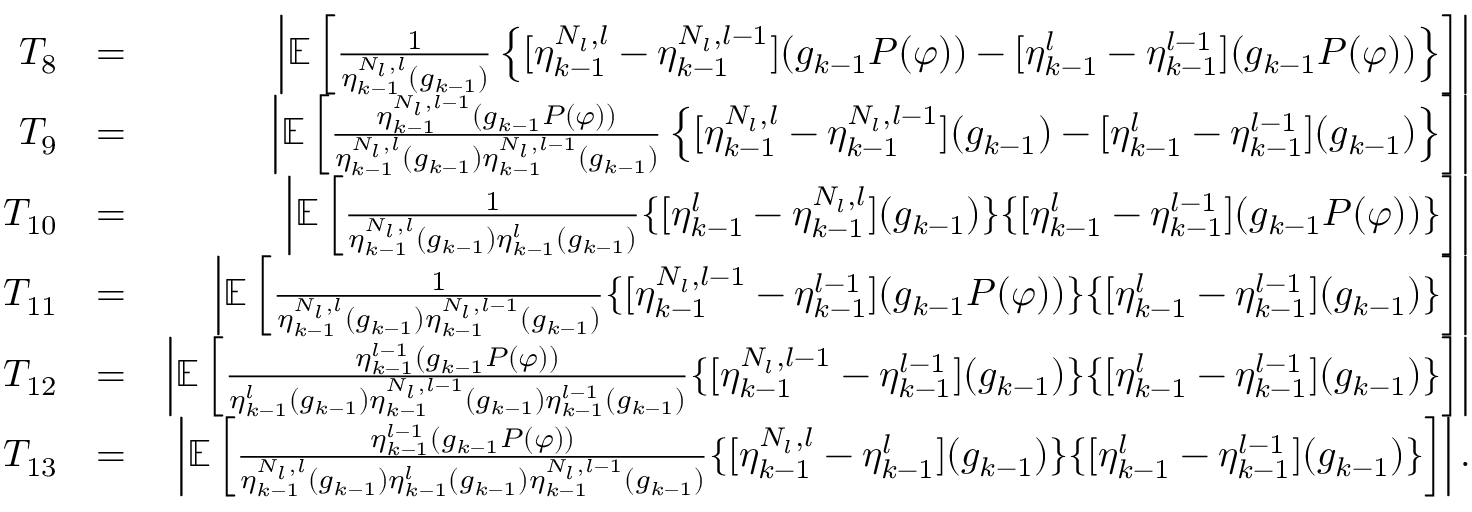<formula> <loc_0><loc_0><loc_500><loc_500>\begin{array} { r l r } { T _ { 8 } } & { = } & { \left | \mathbb { E } \left [ \frac { 1 } { \eta _ { k - 1 } ^ { N _ { l } , l } ( g _ { k - 1 } ) } \left \{ [ \eta _ { k - 1 } ^ { N _ { l } , l } - \eta _ { k - 1 } ^ { N _ { l } , l - 1 } ] ( g _ { k - 1 } P ( \varphi ) ) - [ \eta _ { k - 1 } ^ { l } - \eta _ { k - 1 } ^ { l - 1 } ] ( g _ { k - 1 } P ( \varphi ) ) \right \} \right ] \right | } \\ { T _ { 9 } } & { = } & { \left | \mathbb { E } \left [ \frac { \eta _ { k - 1 } ^ { N _ { l } , l - 1 } ( g _ { k - 1 } P ( \varphi ) ) } { \eta _ { k - 1 } ^ { N _ { l } , l } ( g _ { k - 1 } ) \eta _ { k - 1 } ^ { N _ { l } , l - 1 } ( g _ { k - 1 } ) } \left \{ [ \eta _ { k - 1 } ^ { N _ { l } , l } - \eta _ { k - 1 } ^ { N _ { l } , l - 1 } ] ( g _ { k - 1 } ) - [ \eta _ { k - 1 } ^ { l } - \eta _ { k - 1 } ^ { l - 1 } ] ( g _ { k - 1 } ) \right \} \right ] \right | } \\ { T _ { 1 0 } } & { = } & { \left | \mathbb { E } \left [ \frac { 1 } { \eta _ { k - 1 } ^ { N _ { l } , l } ( g _ { k - 1 } ) \eta _ { k - 1 } ^ { l } ( g _ { k - 1 } ) } \{ [ \eta _ { k - 1 } ^ { l } - \eta _ { k - 1 } ^ { N _ { l } , l } ] ( g _ { k - 1 } ) \} \{ [ \eta _ { k - 1 } ^ { l } - \eta _ { k - 1 } ^ { l - 1 } ] ( g _ { k - 1 } P ( \varphi ) ) \} \right ] \right | } \\ { T _ { 1 1 } } & { = } & { \left | \mathbb { E } \left [ \frac { 1 } { \eta _ { k - 1 } ^ { N _ { l } , l } ( g _ { k - 1 } ) \eta _ { k - 1 } ^ { N _ { l } , l - 1 } ( g _ { k - 1 } ) } \{ [ \eta _ { k - 1 } ^ { N _ { l } , l - 1 } - \eta _ { k - 1 } ^ { l - 1 } ] ( g _ { k - 1 } P ( \varphi ) ) \} \{ [ \eta _ { k - 1 } ^ { l } - \eta _ { k - 1 } ^ { l - 1 } ] ( g _ { k - 1 } ) \} \right ] \right | } \\ { T _ { 1 2 } } & { = } & { \left | \mathbb { E } \left [ \frac { \eta _ { k - 1 } ^ { l - 1 } ( g _ { k - 1 } P ( \varphi ) ) } { \eta _ { k - 1 } ^ { l } ( g _ { k - 1 } ) \eta _ { k - 1 } ^ { N _ { l } , l - 1 } ( g _ { k - 1 } ) \eta _ { k - 1 } ^ { l - 1 } ( g _ { k - 1 } ) } \{ [ \eta _ { k - 1 } ^ { N _ { l } , l - 1 } - \eta _ { k - 1 } ^ { l - 1 } ] ( g _ { k - 1 } ) \} \{ [ \eta _ { k - 1 } ^ { l } - \eta _ { k - 1 } ^ { l - 1 } ] ( g _ { k - 1 } ) \} \right ] \right | } \\ { T _ { 1 3 } } & { = } & { \left | \mathbb { E } \left [ \frac { \eta _ { k - 1 } ^ { l - 1 } ( g _ { k - 1 } P ( \varphi ) ) } { \eta _ { k - 1 } ^ { N _ { l } , l } ( g _ { k - 1 } ) \eta _ { k - 1 } ^ { l } ( g _ { k - 1 } ) \eta _ { k - 1 } ^ { N _ { l } , l - 1 } ( g _ { k - 1 } ) } \{ [ \eta _ { k - 1 } ^ { N _ { l } , l } - \eta _ { k - 1 } ^ { l } ] ( g _ { k - 1 } ) \} \{ [ \eta _ { k - 1 } ^ { l } - \eta _ { k - 1 } ^ { l - 1 } ] ( g _ { k - 1 } ) \} \right ] \right | . } \end{array}</formula> 